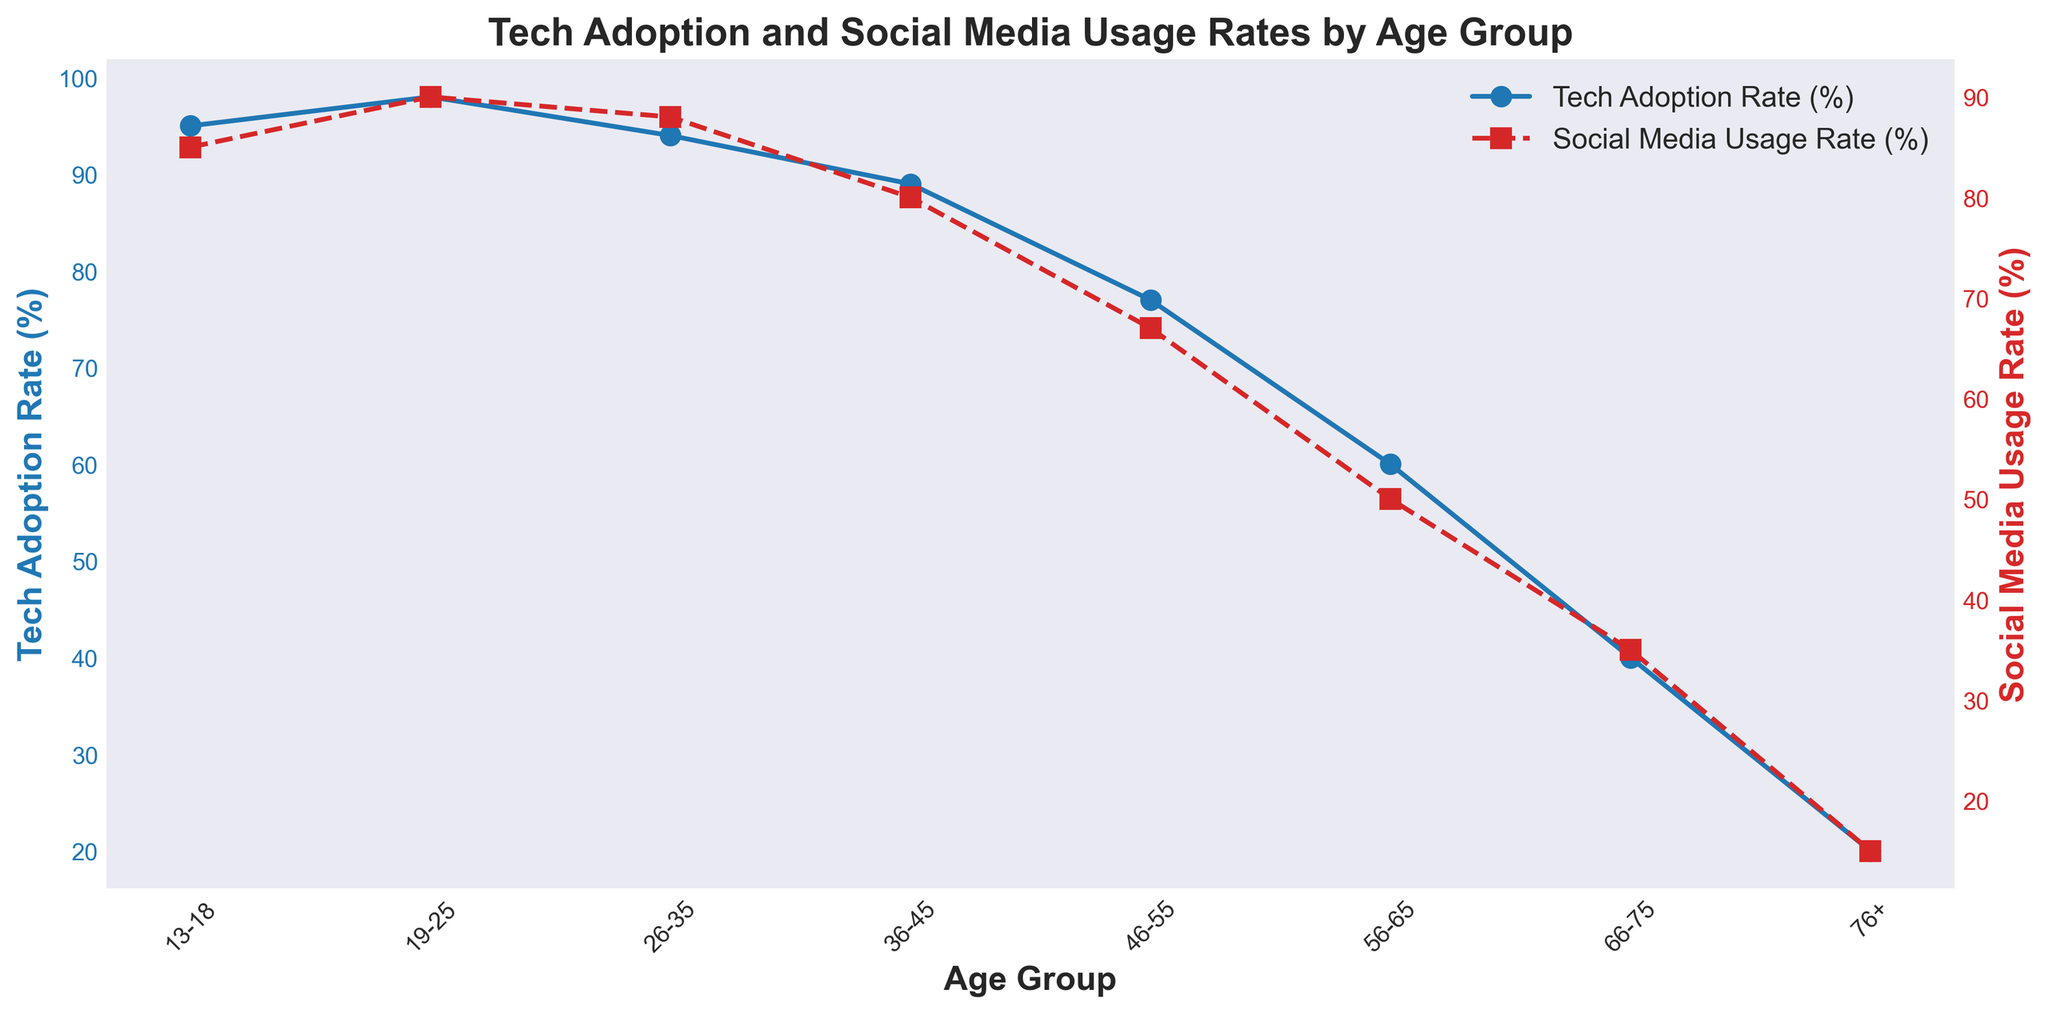What age group has the highest Tech Adoption Rate (%)? By looking at the blue line, we can see that the age group with the highest Tech Adoption Rate is '19-25'.
Answer: 19-25 Which age group has a bigger difference between Tech Adoption Rate (%) and Social Media Usage Rate (%), '36-45' or '46-55'? For '36-45', the difference is 89% - 80% = 9%. For '46-55', the difference is 77% - 67% = 10%. Thus, '46-55' has a bigger difference.
Answer: 46-55 What is the average Social Media Usage Rate (%) for the age groups '56-65' and '66-75'? To find the average, add the Social Media Usage Rate for '56-65' and '66-75', then divide by 2. The values are 50% and 35%. So, (50+35)/2 = 42.5%.
Answer: 42.5% In the age group '13-18', how much higher is Tech Adoption Rate (%) compared to Social Media Usage Rate (%)? Subtract Social Media Usage Rate from Tech Adoption Rate for '13-18'. 95% - 85% = 10%.
Answer: 10% What is the overall trend in Tech Adoption Rate (%) as age increases? The general trend observed from the blue line is a decrease in Tech Adoption Rate (%) as the age group increases.
Answer: Decreases At what age group do both Tech Adoption Rate (%) and Social Media Usage Rate (%) drop below 50%? Both rates are below 50% starting from the age group '66-75'.
Answer: 66-75 For the age group '19-25', how does the Tech Adoption Rate (%) compare to the Social Media Usage Rate (%) visually? For '19-25', the Tech Adoption Rate is represented by the blue line and is higher and more solid, while the Social Media Usage Rate is represented by the red dashed line and is slightly lower.
Answer: Tech Adoption Rate is higher 